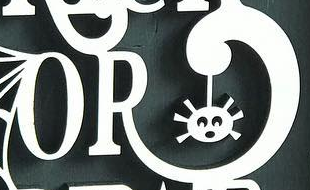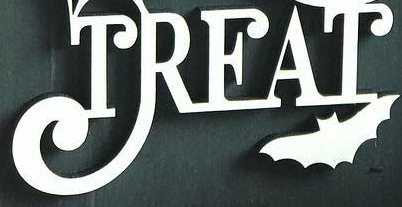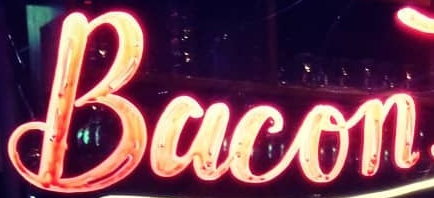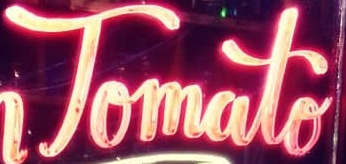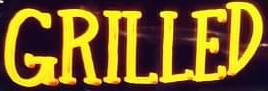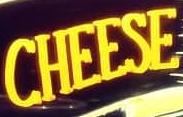Read the text from these images in sequence, separated by a semicolon. OR; TREAT; Bacon; Tomato; GRILLED; CHEESE 